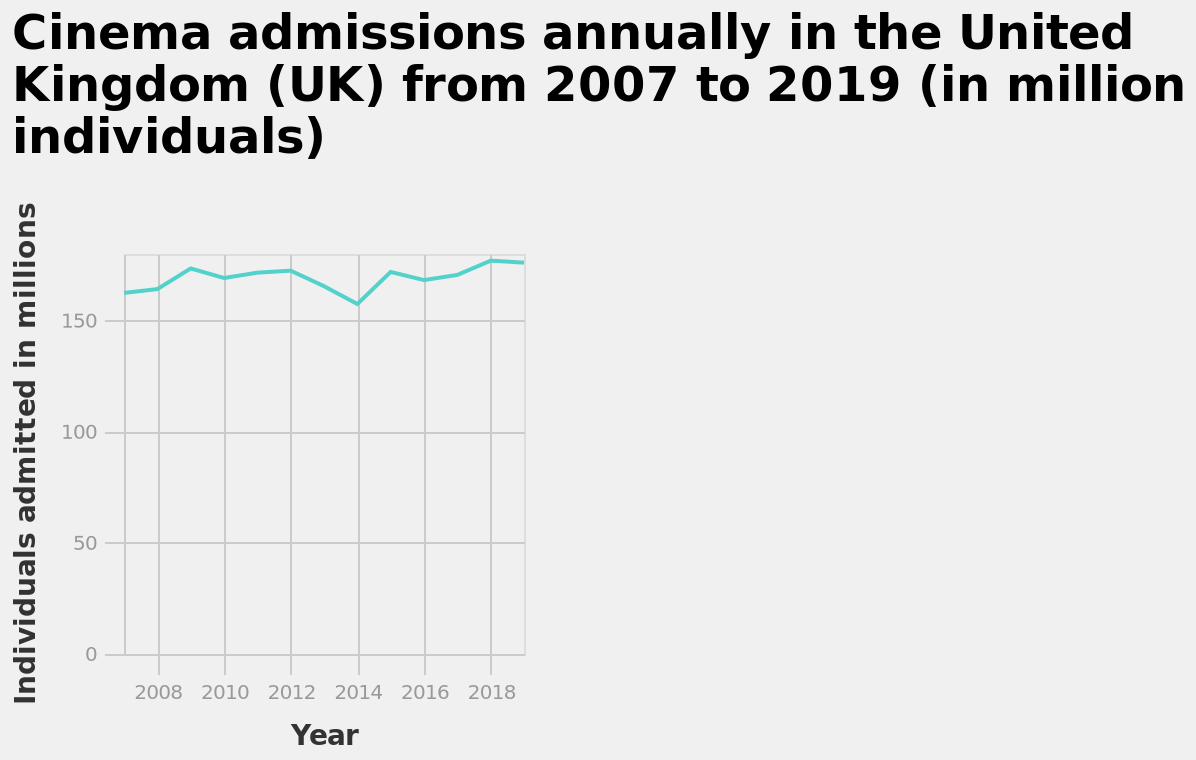<image>
Offer a thorough analysis of the image. The uk cinema industry has never had fewer than 150 million individuals admitted in a single year. The most successful year was 2018. The fewest visitors was in 2014. There has been no upward or downward trend spanning greater than two years. What does the y-axis of the graph represent?  The y-axis of the graph represents the number of individuals admitted to cinemas in millions. How many years of cinema admissions data are presented in the graph? The graph presents 11 years of cinema admissions data from 2008 to 2018. Describe the following image in detail Cinema admissions annually in the United Kingdom (UK) from 2007 to 2019 (in million individuals) is a line graph. A linear scale with a minimum of 2008 and a maximum of 2018 can be found on the x-axis, labeled Year. The y-axis plots Individuals admitted in millions with a linear scale with a minimum of 0 and a maximum of 150. Have cinema admissions always been higher than 150 million admissions?  Yes, cinema admissions have been constantly above 150 million admissions. Has there been any fluctuation in cinema admissions below 150 million admissions?  No, cinema admissions have been constantly above 150 million admissions without any fluctuations below that number. please summary the statistics and relations of the chart Cinema admissions have been constantly above 150 million admissions in the dates studied. 